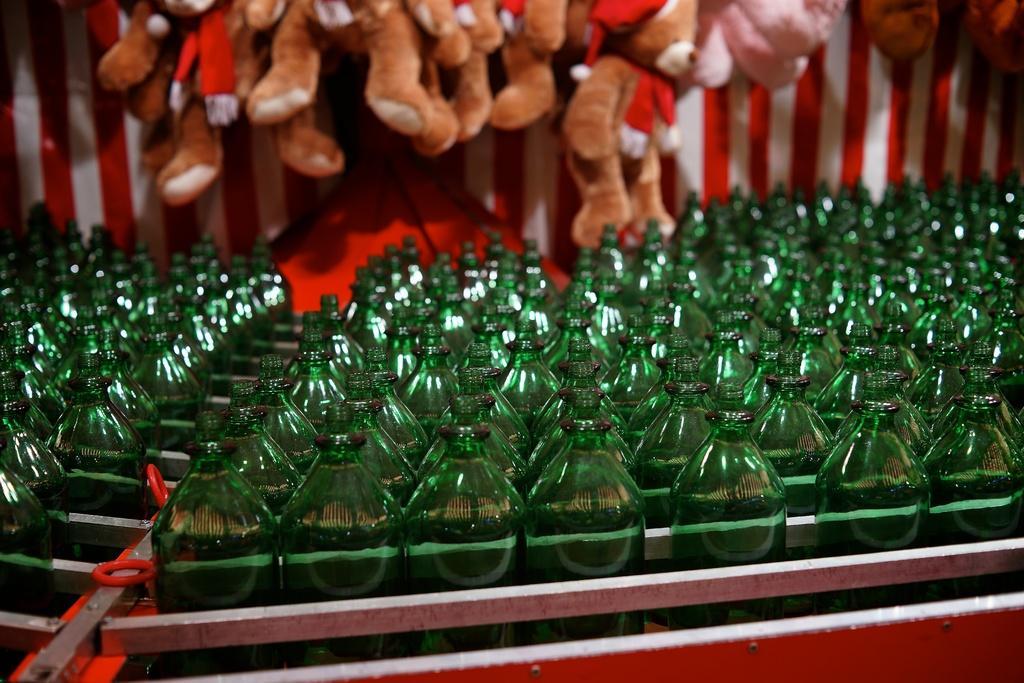Describe this image in one or two sentences. In the image there are case of bottles, in background we can see some toys. 